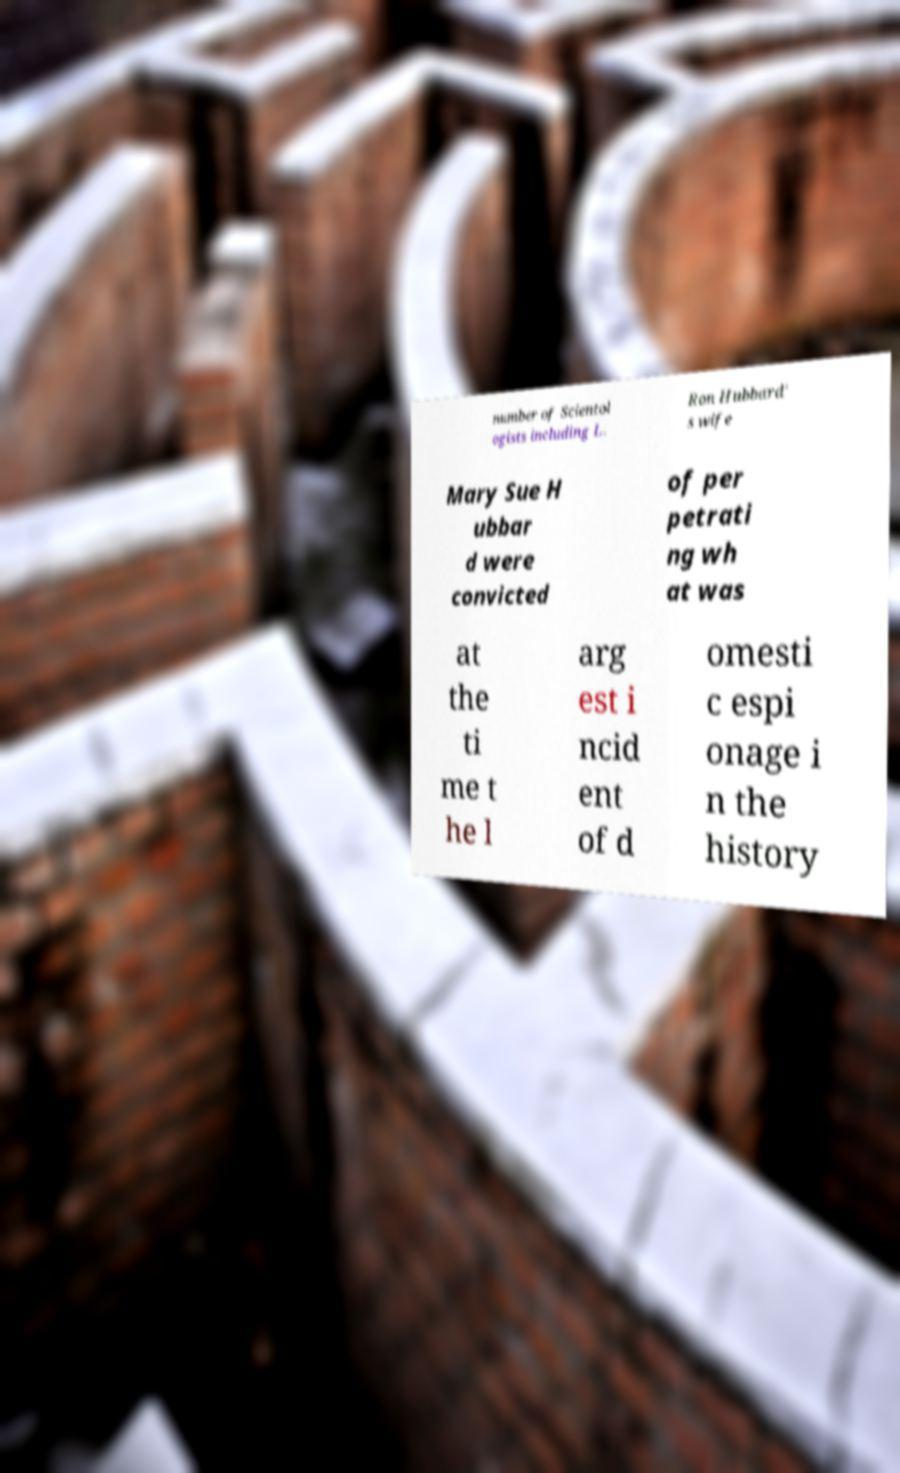What messages or text are displayed in this image? I need them in a readable, typed format. number of Scientol ogists including L. Ron Hubbard' s wife Mary Sue H ubbar d were convicted of per petrati ng wh at was at the ti me t he l arg est i ncid ent of d omesti c espi onage i n the history 